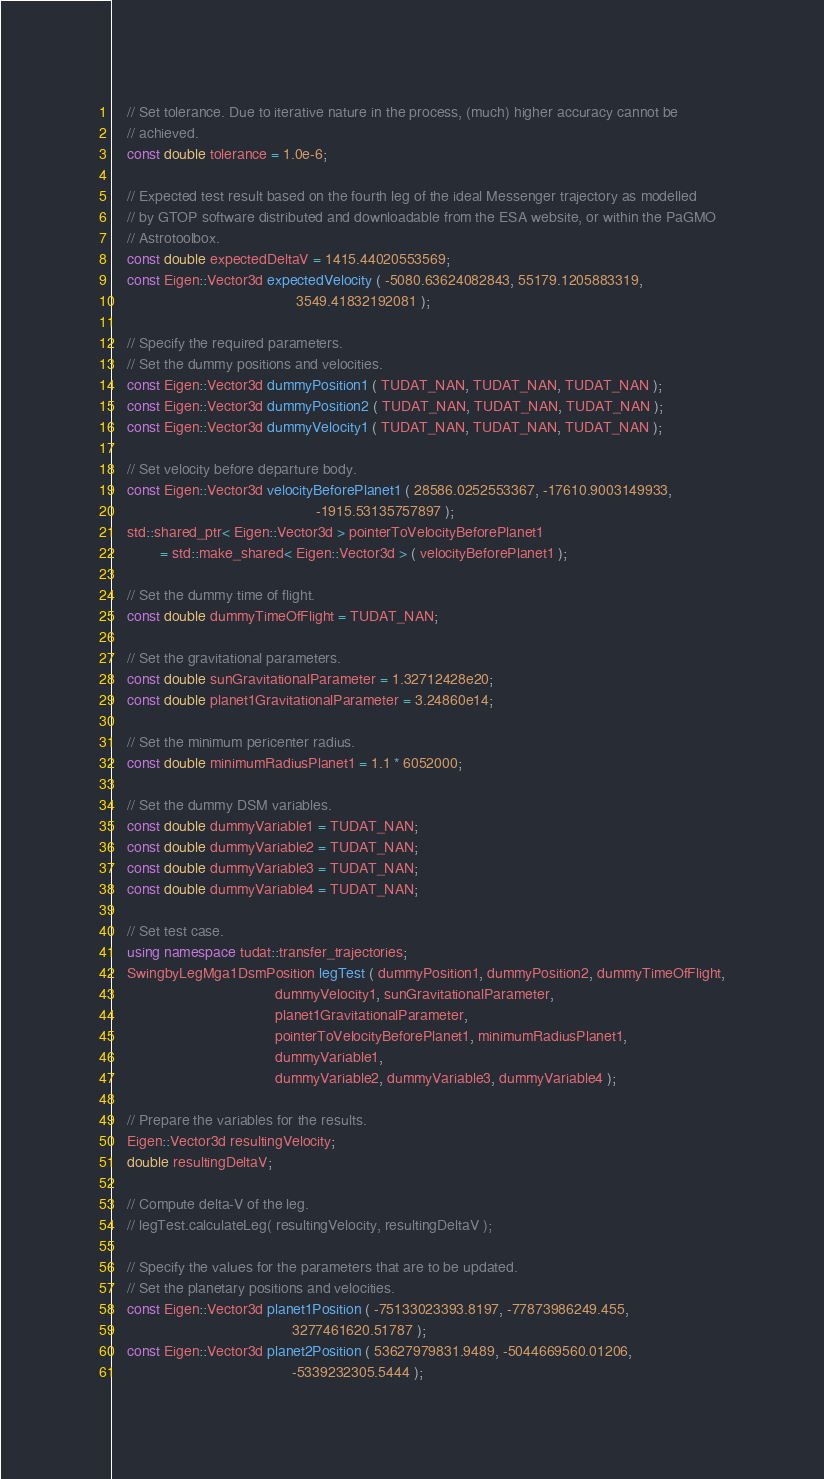<code> <loc_0><loc_0><loc_500><loc_500><_C++_>    // Set tolerance. Due to iterative nature in the process, (much) higher accuracy cannot be
    // achieved.
    const double tolerance = 1.0e-6;

    // Expected test result based on the fourth leg of the ideal Messenger trajectory as modelled
    // by GTOP software distributed and downloadable from the ESA website, or within the PaGMO
    // Astrotoolbox.
    const double expectedDeltaV = 1415.44020553569;
    const Eigen::Vector3d expectedVelocity ( -5080.63624082843, 55179.1205883319,
                                             3549.41832192081 );

    // Specify the required parameters.
    // Set the dummy positions and velocities.
    const Eigen::Vector3d dummyPosition1 ( TUDAT_NAN, TUDAT_NAN, TUDAT_NAN );
    const Eigen::Vector3d dummyPosition2 ( TUDAT_NAN, TUDAT_NAN, TUDAT_NAN );
    const Eigen::Vector3d dummyVelocity1 ( TUDAT_NAN, TUDAT_NAN, TUDAT_NAN );

    // Set velocity before departure body.
    const Eigen::Vector3d velocityBeforePlanet1 ( 28586.0252553367, -17610.9003149933,
                                                  -1915.53135757897 );
    std::shared_ptr< Eigen::Vector3d > pointerToVelocityBeforePlanet1
            = std::make_shared< Eigen::Vector3d > ( velocityBeforePlanet1 );

    // Set the dummy time of flight.
    const double dummyTimeOfFlight = TUDAT_NAN;

    // Set the gravitational parameters.
    const double sunGravitationalParameter = 1.32712428e20;
    const double planet1GravitationalParameter = 3.24860e14;

    // Set the minimum pericenter radius.
    const double minimumRadiusPlanet1 = 1.1 * 6052000;

    // Set the dummy DSM variables.
    const double dummyVariable1 = TUDAT_NAN;
    const double dummyVariable2 = TUDAT_NAN;
    const double dummyVariable3 = TUDAT_NAN;
    const double dummyVariable4 = TUDAT_NAN;

    // Set test case.
    using namespace tudat::transfer_trajectories;
    SwingbyLegMga1DsmPosition legTest ( dummyPosition1, dummyPosition2, dummyTimeOfFlight,
                                        dummyVelocity1, sunGravitationalParameter,
                                        planet1GravitationalParameter,
                                        pointerToVelocityBeforePlanet1, minimumRadiusPlanet1,
                                        dummyVariable1,
                                        dummyVariable2, dummyVariable3, dummyVariable4 );

    // Prepare the variables for the results.
    Eigen::Vector3d resultingVelocity;
    double resultingDeltaV;

    // Compute delta-V of the leg.
    // legTest.calculateLeg( resultingVelocity, resultingDeltaV );

    // Specify the values for the parameters that are to be updated.
    // Set the planetary positions and velocities.
    const Eigen::Vector3d planet1Position ( -75133023393.8197, -77873986249.455,
                                            3277461620.51787 );
    const Eigen::Vector3d planet2Position ( 53627979831.9489, -5044669560.01206,
                                            -5339232305.5444 );</code> 